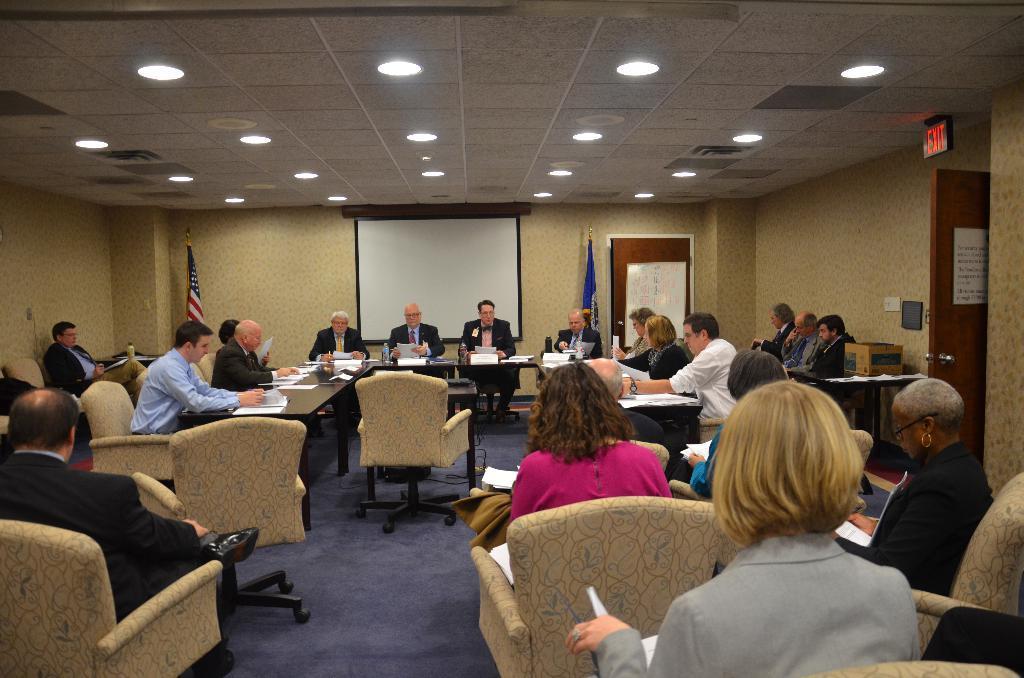Please provide a concise description of this image. In this image we can see some people, tables, chairs, whiteboard, door, lights and flags. 